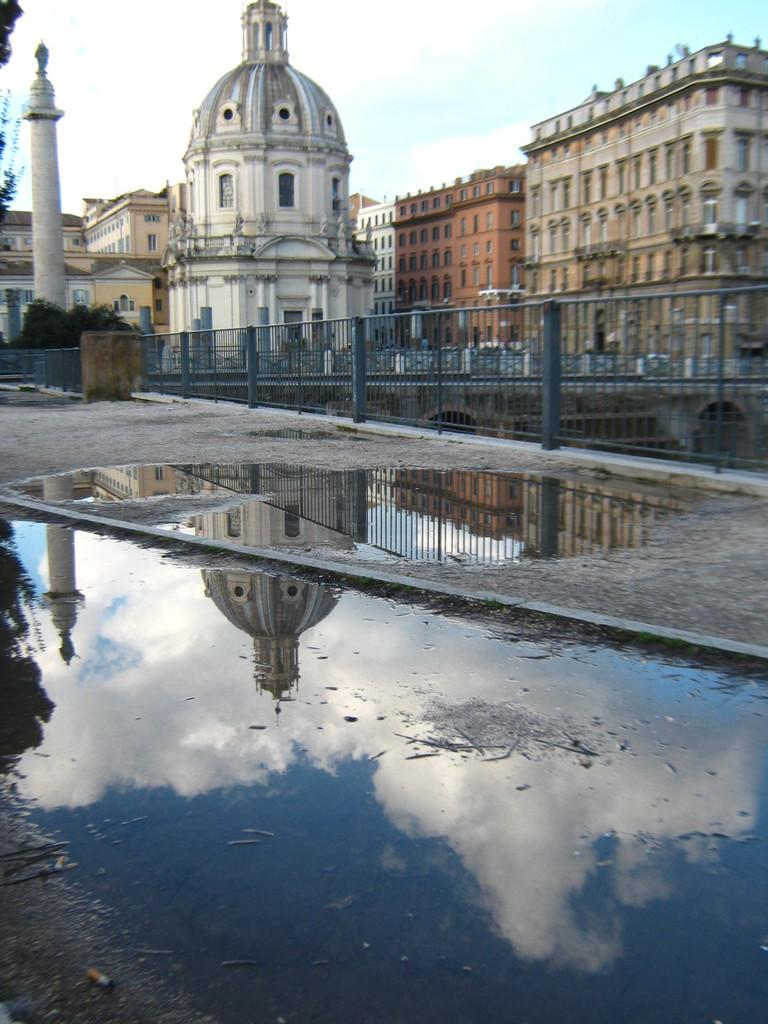Where was the picture taken? The picture was clicked outside a house. What can be seen in the foreground of the image? There are plants and a railing in the foreground of the image, along with some water. What is visible in the center of the image? There are buildings in the center of the image. What can be seen in the sky in the image? The sky is visible and has some clouds. What type of brass instrument is being played in the image? There is no brass instrument or any musical instrument visible in the image. 